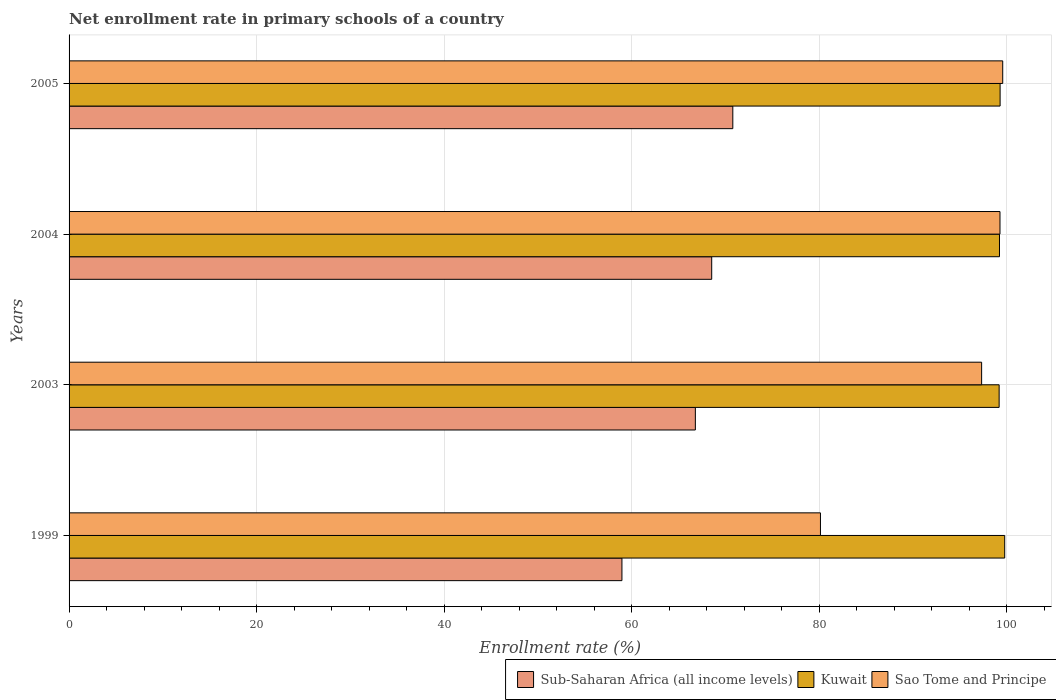How many different coloured bars are there?
Your answer should be compact. 3. How many groups of bars are there?
Your answer should be very brief. 4. How many bars are there on the 2nd tick from the bottom?
Provide a short and direct response. 3. What is the label of the 1st group of bars from the top?
Make the answer very short. 2005. What is the enrollment rate in primary schools in Sub-Saharan Africa (all income levels) in 2004?
Make the answer very short. 68.55. Across all years, what is the maximum enrollment rate in primary schools in Sao Tome and Principe?
Provide a short and direct response. 99.6. Across all years, what is the minimum enrollment rate in primary schools in Kuwait?
Keep it short and to the point. 99.22. In which year was the enrollment rate in primary schools in Kuwait minimum?
Your response must be concise. 2003. What is the total enrollment rate in primary schools in Sao Tome and Principe in the graph?
Offer a terse response. 376.4. What is the difference between the enrollment rate in primary schools in Kuwait in 2003 and that in 2004?
Your answer should be compact. -0.04. What is the difference between the enrollment rate in primary schools in Sub-Saharan Africa (all income levels) in 1999 and the enrollment rate in primary schools in Kuwait in 2003?
Keep it short and to the point. -40.24. What is the average enrollment rate in primary schools in Kuwait per year?
Provide a succinct answer. 99.4. In the year 2004, what is the difference between the enrollment rate in primary schools in Sao Tome and Principe and enrollment rate in primary schools in Kuwait?
Provide a short and direct response. 0.05. In how many years, is the enrollment rate in primary schools in Kuwait greater than 12 %?
Your answer should be compact. 4. What is the ratio of the enrollment rate in primary schools in Kuwait in 2003 to that in 2005?
Your answer should be compact. 1. Is the difference between the enrollment rate in primary schools in Sao Tome and Principe in 1999 and 2003 greater than the difference between the enrollment rate in primary schools in Kuwait in 1999 and 2003?
Provide a succinct answer. No. What is the difference between the highest and the second highest enrollment rate in primary schools in Kuwait?
Provide a short and direct response. 0.49. What is the difference between the highest and the lowest enrollment rate in primary schools in Sub-Saharan Africa (all income levels)?
Make the answer very short. 11.83. Is the sum of the enrollment rate in primary schools in Sub-Saharan Africa (all income levels) in 2003 and 2004 greater than the maximum enrollment rate in primary schools in Sao Tome and Principe across all years?
Provide a short and direct response. Yes. What does the 1st bar from the top in 2005 represents?
Your answer should be very brief. Sao Tome and Principe. What does the 3rd bar from the bottom in 1999 represents?
Provide a succinct answer. Sao Tome and Principe. Is it the case that in every year, the sum of the enrollment rate in primary schools in Sub-Saharan Africa (all income levels) and enrollment rate in primary schools in Kuwait is greater than the enrollment rate in primary schools in Sao Tome and Principe?
Keep it short and to the point. Yes. How many bars are there?
Offer a very short reply. 12. What is the difference between two consecutive major ticks on the X-axis?
Make the answer very short. 20. What is the title of the graph?
Offer a terse response. Net enrollment rate in primary schools of a country. Does "Estonia" appear as one of the legend labels in the graph?
Provide a succinct answer. No. What is the label or title of the X-axis?
Provide a succinct answer. Enrollment rate (%). What is the Enrollment rate (%) of Sub-Saharan Africa (all income levels) in 1999?
Your answer should be compact. 58.98. What is the Enrollment rate (%) of Kuwait in 1999?
Keep it short and to the point. 99.81. What is the Enrollment rate (%) in Sao Tome and Principe in 1999?
Provide a succinct answer. 80.15. What is the Enrollment rate (%) of Sub-Saharan Africa (all income levels) in 2003?
Make the answer very short. 66.81. What is the Enrollment rate (%) in Kuwait in 2003?
Provide a succinct answer. 99.22. What is the Enrollment rate (%) in Sao Tome and Principe in 2003?
Give a very brief answer. 97.35. What is the Enrollment rate (%) of Sub-Saharan Africa (all income levels) in 2004?
Keep it short and to the point. 68.55. What is the Enrollment rate (%) of Kuwait in 2004?
Make the answer very short. 99.25. What is the Enrollment rate (%) in Sao Tome and Principe in 2004?
Make the answer very short. 99.31. What is the Enrollment rate (%) of Sub-Saharan Africa (all income levels) in 2005?
Your answer should be compact. 70.8. What is the Enrollment rate (%) in Kuwait in 2005?
Offer a very short reply. 99.32. What is the Enrollment rate (%) in Sao Tome and Principe in 2005?
Ensure brevity in your answer.  99.6. Across all years, what is the maximum Enrollment rate (%) in Sub-Saharan Africa (all income levels)?
Make the answer very short. 70.8. Across all years, what is the maximum Enrollment rate (%) in Kuwait?
Keep it short and to the point. 99.81. Across all years, what is the maximum Enrollment rate (%) in Sao Tome and Principe?
Ensure brevity in your answer.  99.6. Across all years, what is the minimum Enrollment rate (%) of Sub-Saharan Africa (all income levels)?
Your answer should be very brief. 58.98. Across all years, what is the minimum Enrollment rate (%) of Kuwait?
Your response must be concise. 99.22. Across all years, what is the minimum Enrollment rate (%) of Sao Tome and Principe?
Your answer should be compact. 80.15. What is the total Enrollment rate (%) in Sub-Saharan Africa (all income levels) in the graph?
Give a very brief answer. 265.14. What is the total Enrollment rate (%) of Kuwait in the graph?
Provide a succinct answer. 397.59. What is the total Enrollment rate (%) of Sao Tome and Principe in the graph?
Your answer should be very brief. 376.4. What is the difference between the Enrollment rate (%) in Sub-Saharan Africa (all income levels) in 1999 and that in 2003?
Your response must be concise. -7.83. What is the difference between the Enrollment rate (%) of Kuwait in 1999 and that in 2003?
Provide a succinct answer. 0.59. What is the difference between the Enrollment rate (%) of Sao Tome and Principe in 1999 and that in 2003?
Your answer should be very brief. -17.19. What is the difference between the Enrollment rate (%) in Sub-Saharan Africa (all income levels) in 1999 and that in 2004?
Your response must be concise. -9.58. What is the difference between the Enrollment rate (%) in Kuwait in 1999 and that in 2004?
Provide a succinct answer. 0.56. What is the difference between the Enrollment rate (%) of Sao Tome and Principe in 1999 and that in 2004?
Ensure brevity in your answer.  -19.15. What is the difference between the Enrollment rate (%) in Sub-Saharan Africa (all income levels) in 1999 and that in 2005?
Your response must be concise. -11.83. What is the difference between the Enrollment rate (%) in Kuwait in 1999 and that in 2005?
Make the answer very short. 0.49. What is the difference between the Enrollment rate (%) in Sao Tome and Principe in 1999 and that in 2005?
Give a very brief answer. -19.44. What is the difference between the Enrollment rate (%) of Sub-Saharan Africa (all income levels) in 2003 and that in 2004?
Your response must be concise. -1.74. What is the difference between the Enrollment rate (%) of Kuwait in 2003 and that in 2004?
Your answer should be compact. -0.04. What is the difference between the Enrollment rate (%) in Sao Tome and Principe in 2003 and that in 2004?
Offer a very short reply. -1.96. What is the difference between the Enrollment rate (%) in Sub-Saharan Africa (all income levels) in 2003 and that in 2005?
Offer a very short reply. -4. What is the difference between the Enrollment rate (%) of Kuwait in 2003 and that in 2005?
Offer a terse response. -0.1. What is the difference between the Enrollment rate (%) in Sao Tome and Principe in 2003 and that in 2005?
Offer a terse response. -2.25. What is the difference between the Enrollment rate (%) in Sub-Saharan Africa (all income levels) in 2004 and that in 2005?
Make the answer very short. -2.25. What is the difference between the Enrollment rate (%) of Kuwait in 2004 and that in 2005?
Your answer should be very brief. -0.07. What is the difference between the Enrollment rate (%) of Sao Tome and Principe in 2004 and that in 2005?
Offer a very short reply. -0.29. What is the difference between the Enrollment rate (%) in Sub-Saharan Africa (all income levels) in 1999 and the Enrollment rate (%) in Kuwait in 2003?
Your answer should be compact. -40.24. What is the difference between the Enrollment rate (%) in Sub-Saharan Africa (all income levels) in 1999 and the Enrollment rate (%) in Sao Tome and Principe in 2003?
Your answer should be compact. -38.37. What is the difference between the Enrollment rate (%) in Kuwait in 1999 and the Enrollment rate (%) in Sao Tome and Principe in 2003?
Offer a very short reply. 2.46. What is the difference between the Enrollment rate (%) in Sub-Saharan Africa (all income levels) in 1999 and the Enrollment rate (%) in Kuwait in 2004?
Keep it short and to the point. -40.27. What is the difference between the Enrollment rate (%) in Sub-Saharan Africa (all income levels) in 1999 and the Enrollment rate (%) in Sao Tome and Principe in 2004?
Offer a very short reply. -40.33. What is the difference between the Enrollment rate (%) of Kuwait in 1999 and the Enrollment rate (%) of Sao Tome and Principe in 2004?
Your answer should be compact. 0.5. What is the difference between the Enrollment rate (%) in Sub-Saharan Africa (all income levels) in 1999 and the Enrollment rate (%) in Kuwait in 2005?
Your answer should be very brief. -40.34. What is the difference between the Enrollment rate (%) of Sub-Saharan Africa (all income levels) in 1999 and the Enrollment rate (%) of Sao Tome and Principe in 2005?
Your answer should be very brief. -40.62. What is the difference between the Enrollment rate (%) of Kuwait in 1999 and the Enrollment rate (%) of Sao Tome and Principe in 2005?
Make the answer very short. 0.21. What is the difference between the Enrollment rate (%) of Sub-Saharan Africa (all income levels) in 2003 and the Enrollment rate (%) of Kuwait in 2004?
Offer a terse response. -32.44. What is the difference between the Enrollment rate (%) in Sub-Saharan Africa (all income levels) in 2003 and the Enrollment rate (%) in Sao Tome and Principe in 2004?
Provide a succinct answer. -32.5. What is the difference between the Enrollment rate (%) of Kuwait in 2003 and the Enrollment rate (%) of Sao Tome and Principe in 2004?
Give a very brief answer. -0.09. What is the difference between the Enrollment rate (%) in Sub-Saharan Africa (all income levels) in 2003 and the Enrollment rate (%) in Kuwait in 2005?
Your answer should be very brief. -32.51. What is the difference between the Enrollment rate (%) in Sub-Saharan Africa (all income levels) in 2003 and the Enrollment rate (%) in Sao Tome and Principe in 2005?
Provide a short and direct response. -32.79. What is the difference between the Enrollment rate (%) in Kuwait in 2003 and the Enrollment rate (%) in Sao Tome and Principe in 2005?
Offer a very short reply. -0.38. What is the difference between the Enrollment rate (%) in Sub-Saharan Africa (all income levels) in 2004 and the Enrollment rate (%) in Kuwait in 2005?
Offer a terse response. -30.76. What is the difference between the Enrollment rate (%) of Sub-Saharan Africa (all income levels) in 2004 and the Enrollment rate (%) of Sao Tome and Principe in 2005?
Give a very brief answer. -31.04. What is the difference between the Enrollment rate (%) of Kuwait in 2004 and the Enrollment rate (%) of Sao Tome and Principe in 2005?
Your answer should be compact. -0.34. What is the average Enrollment rate (%) of Sub-Saharan Africa (all income levels) per year?
Offer a terse response. 66.29. What is the average Enrollment rate (%) in Kuwait per year?
Your answer should be very brief. 99.4. What is the average Enrollment rate (%) in Sao Tome and Principe per year?
Provide a short and direct response. 94.1. In the year 1999, what is the difference between the Enrollment rate (%) of Sub-Saharan Africa (all income levels) and Enrollment rate (%) of Kuwait?
Offer a terse response. -40.83. In the year 1999, what is the difference between the Enrollment rate (%) in Sub-Saharan Africa (all income levels) and Enrollment rate (%) in Sao Tome and Principe?
Provide a succinct answer. -21.18. In the year 1999, what is the difference between the Enrollment rate (%) in Kuwait and Enrollment rate (%) in Sao Tome and Principe?
Your response must be concise. 19.66. In the year 2003, what is the difference between the Enrollment rate (%) of Sub-Saharan Africa (all income levels) and Enrollment rate (%) of Kuwait?
Ensure brevity in your answer.  -32.41. In the year 2003, what is the difference between the Enrollment rate (%) of Sub-Saharan Africa (all income levels) and Enrollment rate (%) of Sao Tome and Principe?
Your answer should be very brief. -30.54. In the year 2003, what is the difference between the Enrollment rate (%) in Kuwait and Enrollment rate (%) in Sao Tome and Principe?
Provide a succinct answer. 1.87. In the year 2004, what is the difference between the Enrollment rate (%) of Sub-Saharan Africa (all income levels) and Enrollment rate (%) of Kuwait?
Your answer should be very brief. -30.7. In the year 2004, what is the difference between the Enrollment rate (%) of Sub-Saharan Africa (all income levels) and Enrollment rate (%) of Sao Tome and Principe?
Provide a short and direct response. -30.75. In the year 2004, what is the difference between the Enrollment rate (%) of Kuwait and Enrollment rate (%) of Sao Tome and Principe?
Your answer should be compact. -0.05. In the year 2005, what is the difference between the Enrollment rate (%) of Sub-Saharan Africa (all income levels) and Enrollment rate (%) of Kuwait?
Provide a short and direct response. -28.51. In the year 2005, what is the difference between the Enrollment rate (%) of Sub-Saharan Africa (all income levels) and Enrollment rate (%) of Sao Tome and Principe?
Ensure brevity in your answer.  -28.79. In the year 2005, what is the difference between the Enrollment rate (%) in Kuwait and Enrollment rate (%) in Sao Tome and Principe?
Provide a short and direct response. -0.28. What is the ratio of the Enrollment rate (%) of Sub-Saharan Africa (all income levels) in 1999 to that in 2003?
Your answer should be compact. 0.88. What is the ratio of the Enrollment rate (%) of Sao Tome and Principe in 1999 to that in 2003?
Your answer should be compact. 0.82. What is the ratio of the Enrollment rate (%) in Sub-Saharan Africa (all income levels) in 1999 to that in 2004?
Make the answer very short. 0.86. What is the ratio of the Enrollment rate (%) of Kuwait in 1999 to that in 2004?
Your answer should be compact. 1.01. What is the ratio of the Enrollment rate (%) in Sao Tome and Principe in 1999 to that in 2004?
Your answer should be compact. 0.81. What is the ratio of the Enrollment rate (%) in Sub-Saharan Africa (all income levels) in 1999 to that in 2005?
Offer a very short reply. 0.83. What is the ratio of the Enrollment rate (%) in Sao Tome and Principe in 1999 to that in 2005?
Keep it short and to the point. 0.8. What is the ratio of the Enrollment rate (%) in Sub-Saharan Africa (all income levels) in 2003 to that in 2004?
Offer a very short reply. 0.97. What is the ratio of the Enrollment rate (%) of Kuwait in 2003 to that in 2004?
Provide a short and direct response. 1. What is the ratio of the Enrollment rate (%) of Sao Tome and Principe in 2003 to that in 2004?
Make the answer very short. 0.98. What is the ratio of the Enrollment rate (%) in Sub-Saharan Africa (all income levels) in 2003 to that in 2005?
Keep it short and to the point. 0.94. What is the ratio of the Enrollment rate (%) of Sao Tome and Principe in 2003 to that in 2005?
Your answer should be very brief. 0.98. What is the ratio of the Enrollment rate (%) in Sub-Saharan Africa (all income levels) in 2004 to that in 2005?
Provide a succinct answer. 0.97. What is the difference between the highest and the second highest Enrollment rate (%) of Sub-Saharan Africa (all income levels)?
Offer a very short reply. 2.25. What is the difference between the highest and the second highest Enrollment rate (%) in Kuwait?
Your answer should be compact. 0.49. What is the difference between the highest and the second highest Enrollment rate (%) of Sao Tome and Principe?
Make the answer very short. 0.29. What is the difference between the highest and the lowest Enrollment rate (%) in Sub-Saharan Africa (all income levels)?
Provide a short and direct response. 11.83. What is the difference between the highest and the lowest Enrollment rate (%) of Kuwait?
Ensure brevity in your answer.  0.59. What is the difference between the highest and the lowest Enrollment rate (%) in Sao Tome and Principe?
Your answer should be compact. 19.44. 